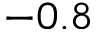Convert formula to latex. <formula><loc_0><loc_0><loc_500><loc_500>- 0 . 8</formula> 